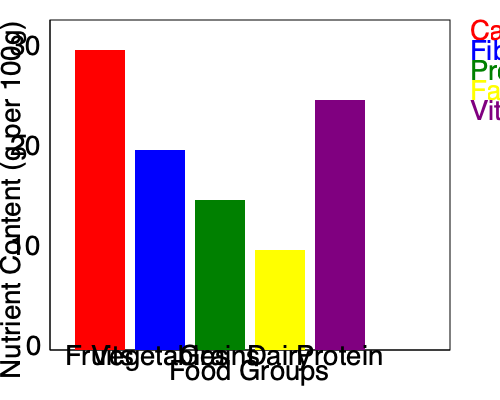Based on the nutrient content graph, which food group would you recommend to a client who needs to increase their fiber intake while maintaining a balanced diet? Explain your reasoning, considering the overall nutrient profile and potential behavioral implications. To answer this question, we need to analyze the nutrient content of each food group and consider the behavioral aspects of diet adherence:

1. Examine the fiber content (blue bars) across food groups:
   - Fruits: Second highest fiber content
   - Vegetables: Highest fiber content
   - Grains: Moderate fiber content
   - Dairy: Low fiber content
   - Protein: Low fiber content

2. Consider overall nutrient profiles:
   - Vegetables have high fiber, moderate carbohydrates, and high vitamins/minerals
   - Fruits have high fiber, high carbohydrates, and high vitamins/minerals

3. Behavioral implications:
   - Increasing vegetable intake often requires more behavioral change than increasing fruit intake
   - Fruits are generally more palatable and easier to incorporate into daily routines

4. Balanced diet considerations:
   - Both fruits and vegetables provide essential nutrients without excessive calories
   - Incorporating both can help maintain diet variety and adherence

Given these factors, recommending an increase in both fruit and vegetable intake would be ideal. However, if we must choose one, fruits would be the best recommendation for most clients. They offer high fiber content, are nutrient-dense, and are typically easier to incorporate into daily eating habits, which is crucial for long-term behavioral change and diet adherence.
Answer: Fruits, due to high fiber content, nutrient density, and ease of incorporation into daily diet. 